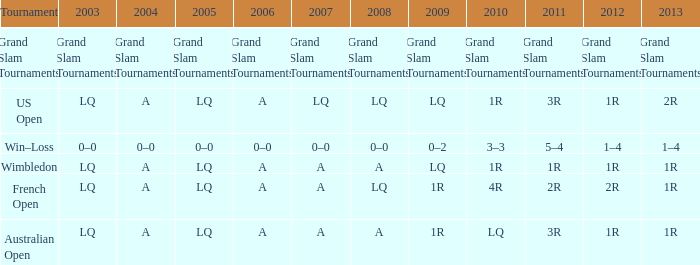Which year has a 2011 of 1r? A. 